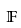Convert formula to latex. <formula><loc_0><loc_0><loc_500><loc_500>\mathbb { F }</formula> 